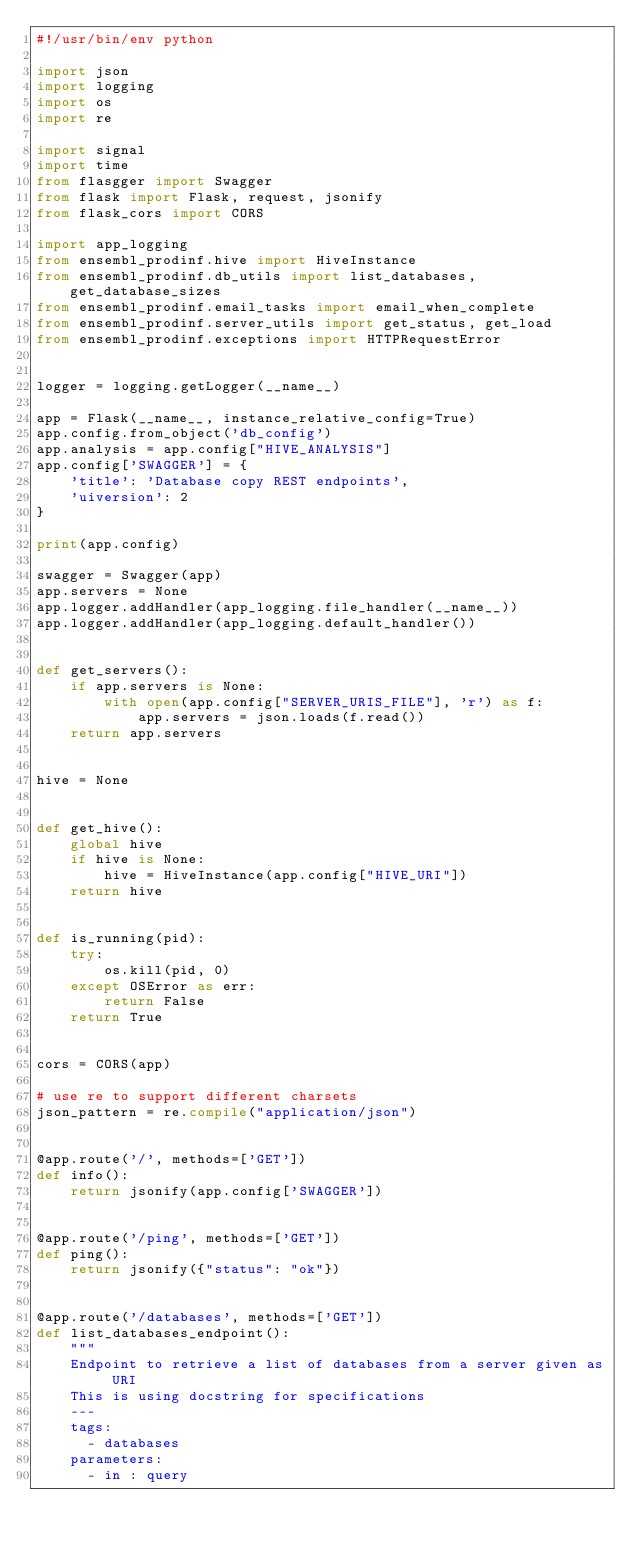Convert code to text. <code><loc_0><loc_0><loc_500><loc_500><_Python_>#!/usr/bin/env python

import json
import logging
import os
import re

import signal
import time
from flasgger import Swagger
from flask import Flask, request, jsonify
from flask_cors import CORS

import app_logging
from ensembl_prodinf.hive import HiveInstance
from ensembl_prodinf.db_utils import list_databases, get_database_sizes
from ensembl_prodinf.email_tasks import email_when_complete
from ensembl_prodinf.server_utils import get_status, get_load
from ensembl_prodinf.exceptions import HTTPRequestError


logger = logging.getLogger(__name__)

app = Flask(__name__, instance_relative_config=True)
app.config.from_object('db_config')
app.analysis = app.config["HIVE_ANALYSIS"]
app.config['SWAGGER'] = {
    'title': 'Database copy REST endpoints',
    'uiversion': 2
}

print(app.config)

swagger = Swagger(app)
app.servers = None
app.logger.addHandler(app_logging.file_handler(__name__))
app.logger.addHandler(app_logging.default_handler())


def get_servers():
    if app.servers is None:
        with open(app.config["SERVER_URIS_FILE"], 'r') as f:
            app.servers = json.loads(f.read())
    return app.servers


hive = None


def get_hive():
    global hive
    if hive is None:
        hive = HiveInstance(app.config["HIVE_URI"])
    return hive


def is_running(pid):
    try:
        os.kill(pid, 0)
    except OSError as err:
        return False
    return True


cors = CORS(app)

# use re to support different charsets
json_pattern = re.compile("application/json")


@app.route('/', methods=['GET'])
def info():
    return jsonify(app.config['SWAGGER'])


@app.route('/ping', methods=['GET'])
def ping():
    return jsonify({"status": "ok"})


@app.route('/databases', methods=['GET'])
def list_databases_endpoint():
    """
    Endpoint to retrieve a list of databases from a server given as URI
    This is using docstring for specifications
    ---
    tags:
      - databases
    parameters:
      - in : query</code> 